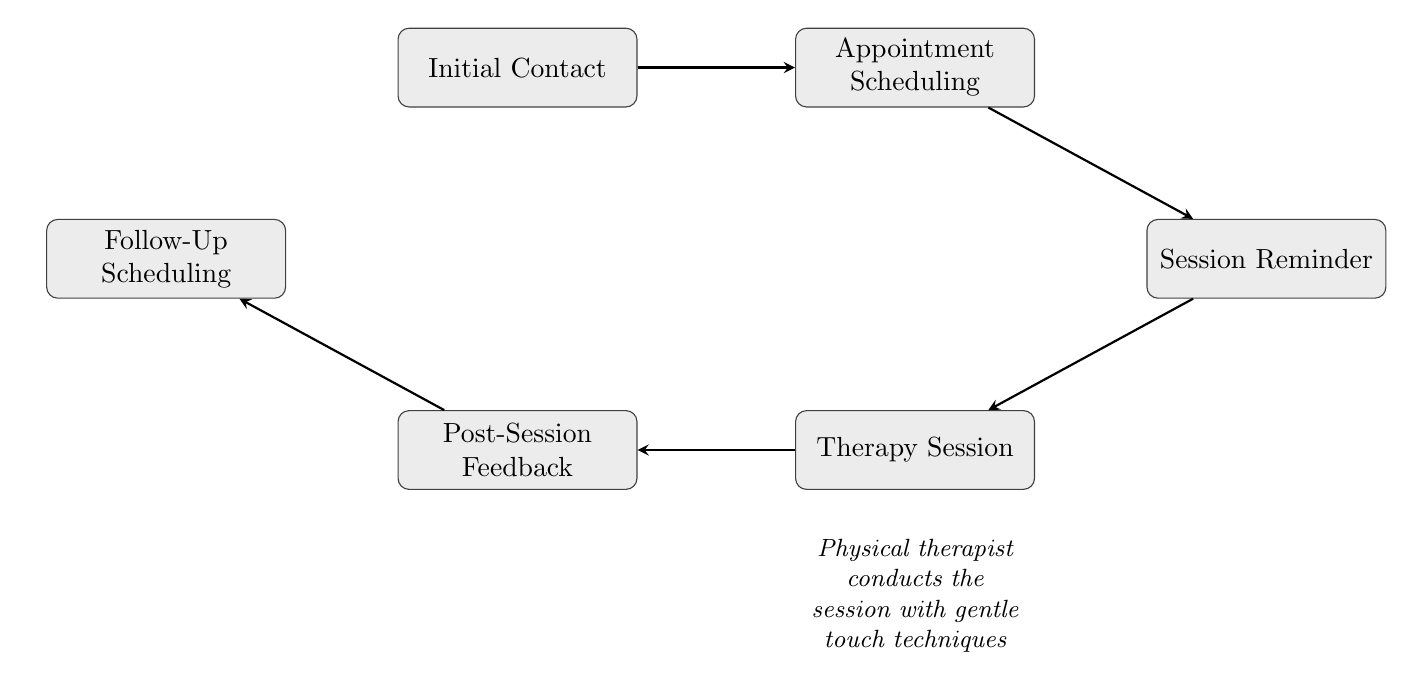What is the first step in the therapy scheduling process? The first node in the flow chart is "Initial Contact," which represents the patient's first interaction with the clinic to schedule an appointment.
Answer: Initial Contact How many nodes are present in the diagram? Counting the nodes listed in the diagram, there are a total of six nodes representing different stages in the therapy scheduling process.
Answer: 6 What type of reminder is sent before the therapy session? The flow chart states that an "Automated reminder" is sent to the patient 24 hours before the appointment, indicating the nature of the reminder.
Answer: Automated reminder What happens immediately after the "Therapy Session"? According to the flow, the next step following "Therapy Session" is "Post-Session Feedback," where the patient provides feedback on the session.
Answer: Post-Session Feedback Which step involves collaboration between the therapist and the patient? "Follow-Up Scheduling" is the step where the therapist and patient work together to schedule the next therapy session, indicating their collaborative effort.
Answer: Follow-Up Scheduling What stage comes just before the "Therapy Session"? The preceding stage directly before "Therapy Session" is "Session Reminder," meaning an automated reminder must be sent out before the actual therapy takes place.
Answer: Session Reminder In how many steps does the process conclude after "Post-Session Feedback"? The flow indicates that following "Post-Session Feedback," there is one final step, which is scheduling the follow-up, thus the entire process concludes in one step after feedback.
Answer: 1 Is there any specific technique mentioned for the therapy session? The description accompanying the "Therapy Session" node indicates that "gentle touch techniques" are specifically employed during the therapy.
Answer: gentle touch techniques What is the relationship between "Appointment Scheduling" and "Session Reminder"? The diagram shows a directed link from "Appointment Scheduling" to "Session Reminder," indicating that the scheduling process directly leads to sending a reminder.
Answer: directs to 